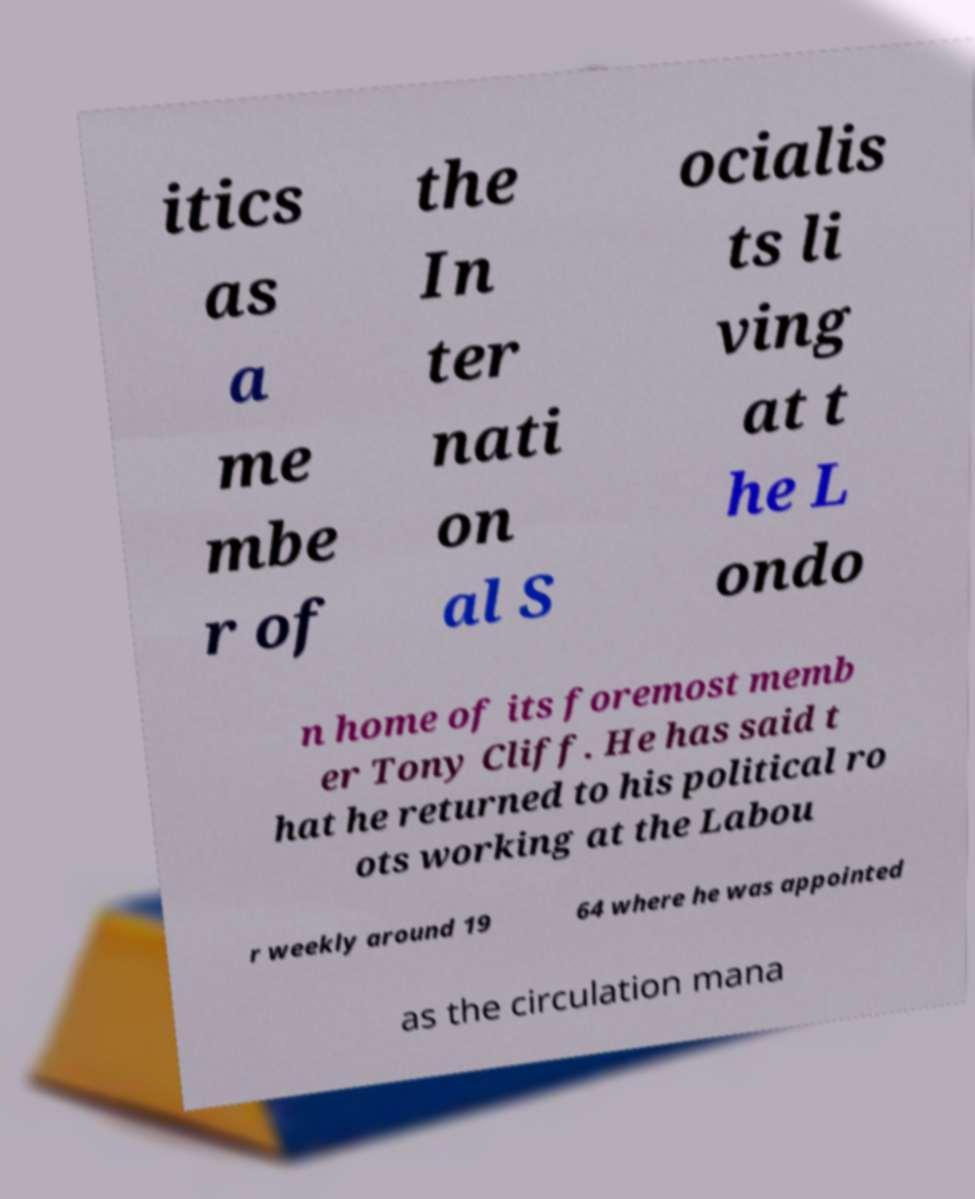Can you read and provide the text displayed in the image?This photo seems to have some interesting text. Can you extract and type it out for me? itics as a me mbe r of the In ter nati on al S ocialis ts li ving at t he L ondo n home of its foremost memb er Tony Cliff. He has said t hat he returned to his political ro ots working at the Labou r weekly around 19 64 where he was appointed as the circulation mana 